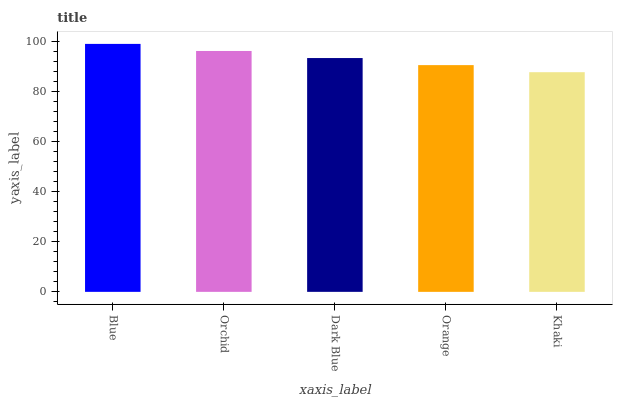Is Khaki the minimum?
Answer yes or no. Yes. Is Blue the maximum?
Answer yes or no. Yes. Is Orchid the minimum?
Answer yes or no. No. Is Orchid the maximum?
Answer yes or no. No. Is Blue greater than Orchid?
Answer yes or no. Yes. Is Orchid less than Blue?
Answer yes or no. Yes. Is Orchid greater than Blue?
Answer yes or no. No. Is Blue less than Orchid?
Answer yes or no. No. Is Dark Blue the high median?
Answer yes or no. Yes. Is Dark Blue the low median?
Answer yes or no. Yes. Is Khaki the high median?
Answer yes or no. No. Is Blue the low median?
Answer yes or no. No. 